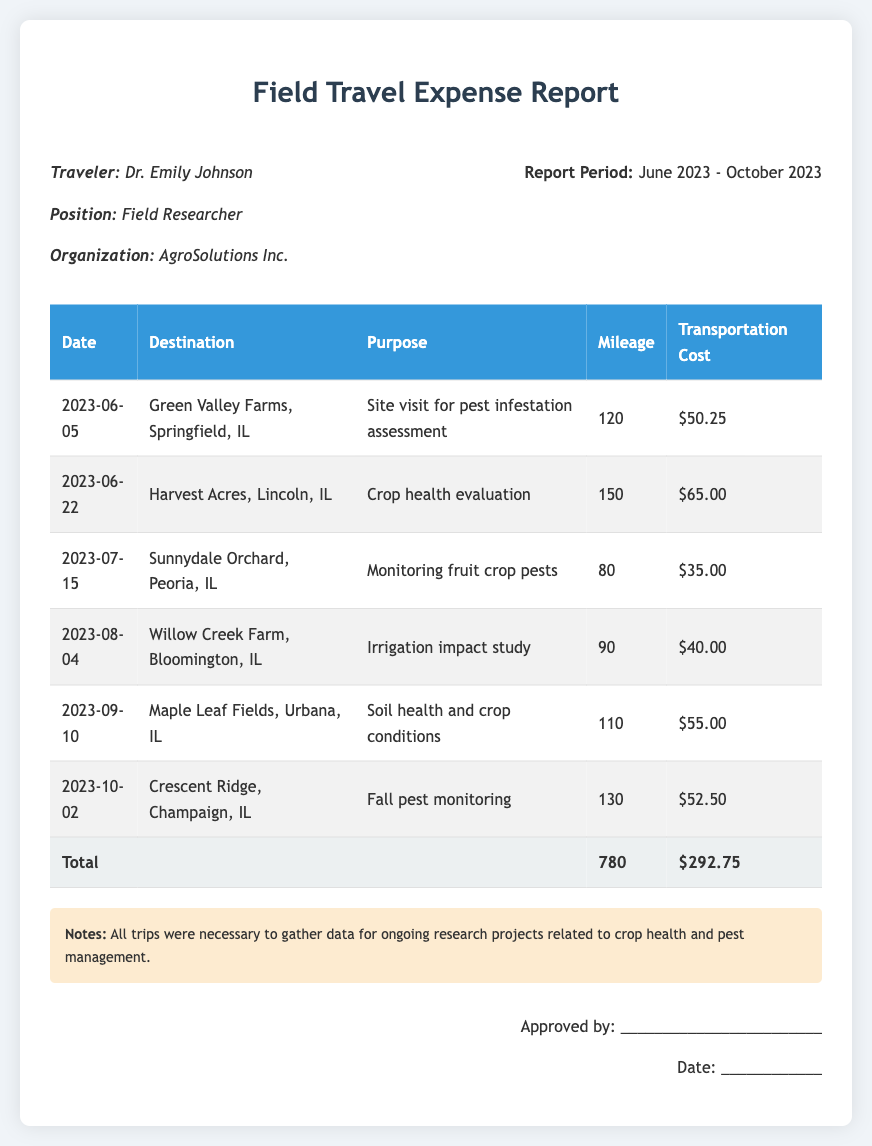What is the traveler's name? The traveler's name is provided in the document, which is Dr. Emily Johnson.
Answer: Dr. Emily Johnson What is the total mileage for the trips? The total mileage is calculated by summing the mileage for all trips listed in the document, which is 120 + 150 + 80 + 90 + 110 + 130 = 780.
Answer: 780 What was the transportation cost for the trip on July 15, 2023? The transportation cost for the trip on July 15, 2023, is explicitly stated in the document as $35.00.
Answer: $35.00 What was the purpose of the visit to Crescent Ridge? The purpose is mentioned in the document as "Fall pest monitoring."
Answer: Fall pest monitoring Which destination had a lower transportation cost, Green Valley Farms or Willow Creek Farm? A comparison of transportation costs reveals that Green Valley Farms has $50.25 and Willow Creek Farm has $40.00, so Willow Creek Farm is lower.
Answer: Willow Creek Farm How many site visits were documented in total? The document lists six trips in total, as counted from the table.
Answer: 6 What is the date of the site visit to Maple Leaf Fields? The date for the Maple Leaf Fields site visit is specifically mentioned in the document as 2023-09-10.
Answer: 2023-09-10 What is the organization of the traveler? The organization of the traveler is provided in the document as AgroSolutions Inc.
Answer: AgroSolutions Inc What is the report period covered in this document? The report period is indicated in the document covering from June 2023 to October 2023.
Answer: June 2023 - October 2023 